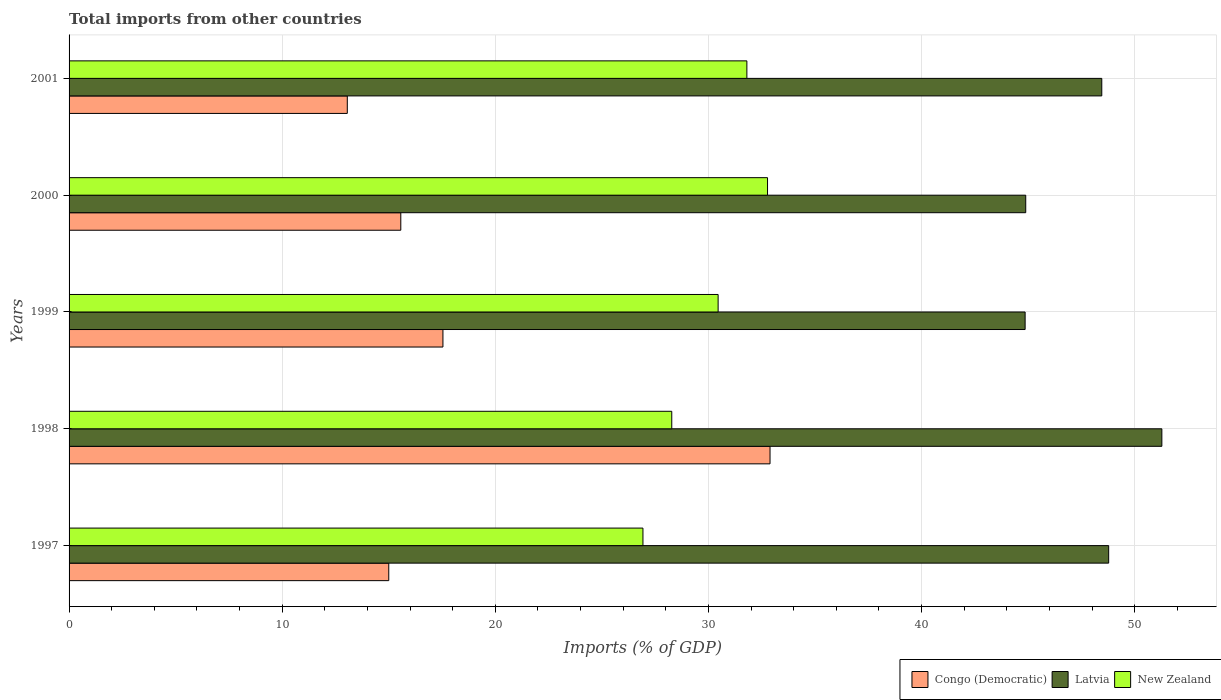How many different coloured bars are there?
Ensure brevity in your answer.  3. Are the number of bars per tick equal to the number of legend labels?
Give a very brief answer. Yes. How many bars are there on the 5th tick from the bottom?
Ensure brevity in your answer.  3. What is the label of the 5th group of bars from the top?
Offer a very short reply. 1997. What is the total imports in New Zealand in 1998?
Your answer should be very brief. 28.28. Across all years, what is the maximum total imports in Congo (Democratic)?
Your response must be concise. 32.89. Across all years, what is the minimum total imports in New Zealand?
Ensure brevity in your answer.  26.93. In which year was the total imports in New Zealand minimum?
Provide a short and direct response. 1997. What is the total total imports in Congo (Democratic) in the graph?
Ensure brevity in your answer.  94.05. What is the difference between the total imports in Congo (Democratic) in 1998 and that in 2001?
Provide a succinct answer. 19.83. What is the difference between the total imports in Congo (Democratic) in 2001 and the total imports in New Zealand in 1999?
Your response must be concise. -17.4. What is the average total imports in New Zealand per year?
Offer a very short reply. 30.05. In the year 1997, what is the difference between the total imports in Latvia and total imports in New Zealand?
Your response must be concise. 21.85. In how many years, is the total imports in Latvia greater than 4 %?
Offer a very short reply. 5. What is the ratio of the total imports in New Zealand in 1997 to that in 2001?
Your answer should be very brief. 0.85. Is the total imports in Congo (Democratic) in 1997 less than that in 2001?
Provide a short and direct response. No. Is the difference between the total imports in Latvia in 1998 and 2000 greater than the difference between the total imports in New Zealand in 1998 and 2000?
Ensure brevity in your answer.  Yes. What is the difference between the highest and the second highest total imports in Congo (Democratic)?
Offer a very short reply. 15.35. What is the difference between the highest and the lowest total imports in Latvia?
Offer a very short reply. 6.42. Is the sum of the total imports in New Zealand in 1998 and 1999 greater than the maximum total imports in Latvia across all years?
Make the answer very short. Yes. What does the 3rd bar from the top in 1999 represents?
Keep it short and to the point. Congo (Democratic). What does the 2nd bar from the bottom in 1998 represents?
Your answer should be compact. Latvia. What is the difference between two consecutive major ticks on the X-axis?
Your answer should be very brief. 10. Are the values on the major ticks of X-axis written in scientific E-notation?
Your response must be concise. No. Does the graph contain grids?
Offer a very short reply. Yes. What is the title of the graph?
Make the answer very short. Total imports from other countries. Does "Jordan" appear as one of the legend labels in the graph?
Give a very brief answer. No. What is the label or title of the X-axis?
Make the answer very short. Imports (% of GDP). What is the label or title of the Y-axis?
Provide a succinct answer. Years. What is the Imports (% of GDP) of Congo (Democratic) in 1997?
Provide a succinct answer. 15. What is the Imports (% of GDP) of Latvia in 1997?
Your response must be concise. 48.78. What is the Imports (% of GDP) of New Zealand in 1997?
Your answer should be very brief. 26.93. What is the Imports (% of GDP) of Congo (Democratic) in 1998?
Provide a succinct answer. 32.89. What is the Imports (% of GDP) in Latvia in 1998?
Your response must be concise. 51.27. What is the Imports (% of GDP) in New Zealand in 1998?
Provide a short and direct response. 28.28. What is the Imports (% of GDP) of Congo (Democratic) in 1999?
Give a very brief answer. 17.54. What is the Imports (% of GDP) in Latvia in 1999?
Your answer should be compact. 44.86. What is the Imports (% of GDP) of New Zealand in 1999?
Provide a short and direct response. 30.45. What is the Imports (% of GDP) of Congo (Democratic) in 2000?
Your response must be concise. 15.56. What is the Imports (% of GDP) of Latvia in 2000?
Offer a very short reply. 44.89. What is the Imports (% of GDP) of New Zealand in 2000?
Your response must be concise. 32.77. What is the Imports (% of GDP) of Congo (Democratic) in 2001?
Your response must be concise. 13.05. What is the Imports (% of GDP) of Latvia in 2001?
Give a very brief answer. 48.46. What is the Imports (% of GDP) in New Zealand in 2001?
Offer a very short reply. 31.8. Across all years, what is the maximum Imports (% of GDP) of Congo (Democratic)?
Offer a very short reply. 32.89. Across all years, what is the maximum Imports (% of GDP) of Latvia?
Make the answer very short. 51.27. Across all years, what is the maximum Imports (% of GDP) of New Zealand?
Give a very brief answer. 32.77. Across all years, what is the minimum Imports (% of GDP) of Congo (Democratic)?
Provide a short and direct response. 13.05. Across all years, what is the minimum Imports (% of GDP) of Latvia?
Keep it short and to the point. 44.86. Across all years, what is the minimum Imports (% of GDP) of New Zealand?
Make the answer very short. 26.93. What is the total Imports (% of GDP) of Congo (Democratic) in the graph?
Provide a short and direct response. 94.05. What is the total Imports (% of GDP) in Latvia in the graph?
Give a very brief answer. 238.25. What is the total Imports (% of GDP) in New Zealand in the graph?
Make the answer very short. 150.23. What is the difference between the Imports (% of GDP) of Congo (Democratic) in 1997 and that in 1998?
Offer a very short reply. -17.89. What is the difference between the Imports (% of GDP) of Latvia in 1997 and that in 1998?
Ensure brevity in your answer.  -2.5. What is the difference between the Imports (% of GDP) of New Zealand in 1997 and that in 1998?
Your answer should be compact. -1.35. What is the difference between the Imports (% of GDP) of Congo (Democratic) in 1997 and that in 1999?
Your response must be concise. -2.54. What is the difference between the Imports (% of GDP) of Latvia in 1997 and that in 1999?
Give a very brief answer. 3.92. What is the difference between the Imports (% of GDP) of New Zealand in 1997 and that in 1999?
Provide a succinct answer. -3.53. What is the difference between the Imports (% of GDP) of Congo (Democratic) in 1997 and that in 2000?
Your answer should be compact. -0.56. What is the difference between the Imports (% of GDP) of Latvia in 1997 and that in 2000?
Ensure brevity in your answer.  3.89. What is the difference between the Imports (% of GDP) in New Zealand in 1997 and that in 2000?
Provide a short and direct response. -5.85. What is the difference between the Imports (% of GDP) of Congo (Democratic) in 1997 and that in 2001?
Ensure brevity in your answer.  1.95. What is the difference between the Imports (% of GDP) of Latvia in 1997 and that in 2001?
Your answer should be very brief. 0.32. What is the difference between the Imports (% of GDP) of New Zealand in 1997 and that in 2001?
Your answer should be compact. -4.88. What is the difference between the Imports (% of GDP) in Congo (Democratic) in 1998 and that in 1999?
Provide a short and direct response. 15.35. What is the difference between the Imports (% of GDP) of Latvia in 1998 and that in 1999?
Keep it short and to the point. 6.42. What is the difference between the Imports (% of GDP) of New Zealand in 1998 and that in 1999?
Ensure brevity in your answer.  -2.18. What is the difference between the Imports (% of GDP) in Congo (Democratic) in 1998 and that in 2000?
Ensure brevity in your answer.  17.32. What is the difference between the Imports (% of GDP) of Latvia in 1998 and that in 2000?
Offer a very short reply. 6.39. What is the difference between the Imports (% of GDP) in New Zealand in 1998 and that in 2000?
Your response must be concise. -4.49. What is the difference between the Imports (% of GDP) in Congo (Democratic) in 1998 and that in 2001?
Ensure brevity in your answer.  19.84. What is the difference between the Imports (% of GDP) of Latvia in 1998 and that in 2001?
Your answer should be compact. 2.82. What is the difference between the Imports (% of GDP) in New Zealand in 1998 and that in 2001?
Offer a very short reply. -3.52. What is the difference between the Imports (% of GDP) in Congo (Democratic) in 1999 and that in 2000?
Make the answer very short. 1.98. What is the difference between the Imports (% of GDP) of Latvia in 1999 and that in 2000?
Give a very brief answer. -0.03. What is the difference between the Imports (% of GDP) in New Zealand in 1999 and that in 2000?
Offer a terse response. -2.32. What is the difference between the Imports (% of GDP) of Congo (Democratic) in 1999 and that in 2001?
Provide a succinct answer. 4.49. What is the difference between the Imports (% of GDP) of Latvia in 1999 and that in 2001?
Your answer should be very brief. -3.6. What is the difference between the Imports (% of GDP) in New Zealand in 1999 and that in 2001?
Your response must be concise. -1.35. What is the difference between the Imports (% of GDP) of Congo (Democratic) in 2000 and that in 2001?
Keep it short and to the point. 2.51. What is the difference between the Imports (% of GDP) of Latvia in 2000 and that in 2001?
Your answer should be compact. -3.57. What is the difference between the Imports (% of GDP) of New Zealand in 2000 and that in 2001?
Ensure brevity in your answer.  0.97. What is the difference between the Imports (% of GDP) in Congo (Democratic) in 1997 and the Imports (% of GDP) in Latvia in 1998?
Give a very brief answer. -36.27. What is the difference between the Imports (% of GDP) of Congo (Democratic) in 1997 and the Imports (% of GDP) of New Zealand in 1998?
Your response must be concise. -13.28. What is the difference between the Imports (% of GDP) in Latvia in 1997 and the Imports (% of GDP) in New Zealand in 1998?
Your answer should be very brief. 20.5. What is the difference between the Imports (% of GDP) in Congo (Democratic) in 1997 and the Imports (% of GDP) in Latvia in 1999?
Offer a terse response. -29.86. What is the difference between the Imports (% of GDP) of Congo (Democratic) in 1997 and the Imports (% of GDP) of New Zealand in 1999?
Ensure brevity in your answer.  -15.45. What is the difference between the Imports (% of GDP) in Latvia in 1997 and the Imports (% of GDP) in New Zealand in 1999?
Make the answer very short. 18.32. What is the difference between the Imports (% of GDP) of Congo (Democratic) in 1997 and the Imports (% of GDP) of Latvia in 2000?
Your answer should be compact. -29.89. What is the difference between the Imports (% of GDP) of Congo (Democratic) in 1997 and the Imports (% of GDP) of New Zealand in 2000?
Offer a very short reply. -17.77. What is the difference between the Imports (% of GDP) of Latvia in 1997 and the Imports (% of GDP) of New Zealand in 2000?
Your answer should be compact. 16.01. What is the difference between the Imports (% of GDP) of Congo (Democratic) in 1997 and the Imports (% of GDP) of Latvia in 2001?
Give a very brief answer. -33.45. What is the difference between the Imports (% of GDP) in Congo (Democratic) in 1997 and the Imports (% of GDP) in New Zealand in 2001?
Offer a very short reply. -16.8. What is the difference between the Imports (% of GDP) of Latvia in 1997 and the Imports (% of GDP) of New Zealand in 2001?
Make the answer very short. 16.98. What is the difference between the Imports (% of GDP) of Congo (Democratic) in 1998 and the Imports (% of GDP) of Latvia in 1999?
Keep it short and to the point. -11.97. What is the difference between the Imports (% of GDP) in Congo (Democratic) in 1998 and the Imports (% of GDP) in New Zealand in 1999?
Keep it short and to the point. 2.44. What is the difference between the Imports (% of GDP) of Latvia in 1998 and the Imports (% of GDP) of New Zealand in 1999?
Keep it short and to the point. 20.82. What is the difference between the Imports (% of GDP) in Congo (Democratic) in 1998 and the Imports (% of GDP) in Latvia in 2000?
Ensure brevity in your answer.  -12. What is the difference between the Imports (% of GDP) in Congo (Democratic) in 1998 and the Imports (% of GDP) in New Zealand in 2000?
Provide a short and direct response. 0.12. What is the difference between the Imports (% of GDP) in Latvia in 1998 and the Imports (% of GDP) in New Zealand in 2000?
Make the answer very short. 18.5. What is the difference between the Imports (% of GDP) in Congo (Democratic) in 1998 and the Imports (% of GDP) in Latvia in 2001?
Offer a very short reply. -15.57. What is the difference between the Imports (% of GDP) in Congo (Democratic) in 1998 and the Imports (% of GDP) in New Zealand in 2001?
Make the answer very short. 1.09. What is the difference between the Imports (% of GDP) of Latvia in 1998 and the Imports (% of GDP) of New Zealand in 2001?
Keep it short and to the point. 19.47. What is the difference between the Imports (% of GDP) of Congo (Democratic) in 1999 and the Imports (% of GDP) of Latvia in 2000?
Provide a succinct answer. -27.35. What is the difference between the Imports (% of GDP) in Congo (Democratic) in 1999 and the Imports (% of GDP) in New Zealand in 2000?
Ensure brevity in your answer.  -15.23. What is the difference between the Imports (% of GDP) of Latvia in 1999 and the Imports (% of GDP) of New Zealand in 2000?
Offer a terse response. 12.09. What is the difference between the Imports (% of GDP) in Congo (Democratic) in 1999 and the Imports (% of GDP) in Latvia in 2001?
Ensure brevity in your answer.  -30.91. What is the difference between the Imports (% of GDP) in Congo (Democratic) in 1999 and the Imports (% of GDP) in New Zealand in 2001?
Your answer should be very brief. -14.26. What is the difference between the Imports (% of GDP) of Latvia in 1999 and the Imports (% of GDP) of New Zealand in 2001?
Your answer should be very brief. 13.06. What is the difference between the Imports (% of GDP) in Congo (Democratic) in 2000 and the Imports (% of GDP) in Latvia in 2001?
Your answer should be very brief. -32.89. What is the difference between the Imports (% of GDP) in Congo (Democratic) in 2000 and the Imports (% of GDP) in New Zealand in 2001?
Offer a terse response. -16.24. What is the difference between the Imports (% of GDP) of Latvia in 2000 and the Imports (% of GDP) of New Zealand in 2001?
Provide a short and direct response. 13.08. What is the average Imports (% of GDP) of Congo (Democratic) per year?
Provide a succinct answer. 18.81. What is the average Imports (% of GDP) in Latvia per year?
Ensure brevity in your answer.  47.65. What is the average Imports (% of GDP) in New Zealand per year?
Your response must be concise. 30.05. In the year 1997, what is the difference between the Imports (% of GDP) in Congo (Democratic) and Imports (% of GDP) in Latvia?
Keep it short and to the point. -33.78. In the year 1997, what is the difference between the Imports (% of GDP) in Congo (Democratic) and Imports (% of GDP) in New Zealand?
Provide a short and direct response. -11.93. In the year 1997, what is the difference between the Imports (% of GDP) in Latvia and Imports (% of GDP) in New Zealand?
Give a very brief answer. 21.85. In the year 1998, what is the difference between the Imports (% of GDP) of Congo (Democratic) and Imports (% of GDP) of Latvia?
Provide a short and direct response. -18.38. In the year 1998, what is the difference between the Imports (% of GDP) of Congo (Democratic) and Imports (% of GDP) of New Zealand?
Provide a succinct answer. 4.61. In the year 1998, what is the difference between the Imports (% of GDP) of Latvia and Imports (% of GDP) of New Zealand?
Your response must be concise. 23. In the year 1999, what is the difference between the Imports (% of GDP) in Congo (Democratic) and Imports (% of GDP) in Latvia?
Provide a short and direct response. -27.32. In the year 1999, what is the difference between the Imports (% of GDP) of Congo (Democratic) and Imports (% of GDP) of New Zealand?
Keep it short and to the point. -12.91. In the year 1999, what is the difference between the Imports (% of GDP) of Latvia and Imports (% of GDP) of New Zealand?
Give a very brief answer. 14.4. In the year 2000, what is the difference between the Imports (% of GDP) in Congo (Democratic) and Imports (% of GDP) in Latvia?
Offer a terse response. -29.32. In the year 2000, what is the difference between the Imports (% of GDP) of Congo (Democratic) and Imports (% of GDP) of New Zealand?
Your response must be concise. -17.21. In the year 2000, what is the difference between the Imports (% of GDP) of Latvia and Imports (% of GDP) of New Zealand?
Give a very brief answer. 12.12. In the year 2001, what is the difference between the Imports (% of GDP) in Congo (Democratic) and Imports (% of GDP) in Latvia?
Offer a very short reply. -35.4. In the year 2001, what is the difference between the Imports (% of GDP) in Congo (Democratic) and Imports (% of GDP) in New Zealand?
Your response must be concise. -18.75. In the year 2001, what is the difference between the Imports (% of GDP) of Latvia and Imports (% of GDP) of New Zealand?
Offer a terse response. 16.65. What is the ratio of the Imports (% of GDP) in Congo (Democratic) in 1997 to that in 1998?
Ensure brevity in your answer.  0.46. What is the ratio of the Imports (% of GDP) of Latvia in 1997 to that in 1998?
Provide a succinct answer. 0.95. What is the ratio of the Imports (% of GDP) in New Zealand in 1997 to that in 1998?
Ensure brevity in your answer.  0.95. What is the ratio of the Imports (% of GDP) of Congo (Democratic) in 1997 to that in 1999?
Offer a very short reply. 0.86. What is the ratio of the Imports (% of GDP) of Latvia in 1997 to that in 1999?
Your answer should be very brief. 1.09. What is the ratio of the Imports (% of GDP) of New Zealand in 1997 to that in 1999?
Keep it short and to the point. 0.88. What is the ratio of the Imports (% of GDP) of Congo (Democratic) in 1997 to that in 2000?
Offer a very short reply. 0.96. What is the ratio of the Imports (% of GDP) in Latvia in 1997 to that in 2000?
Offer a very short reply. 1.09. What is the ratio of the Imports (% of GDP) of New Zealand in 1997 to that in 2000?
Your answer should be very brief. 0.82. What is the ratio of the Imports (% of GDP) of Congo (Democratic) in 1997 to that in 2001?
Make the answer very short. 1.15. What is the ratio of the Imports (% of GDP) of New Zealand in 1997 to that in 2001?
Make the answer very short. 0.85. What is the ratio of the Imports (% of GDP) of Congo (Democratic) in 1998 to that in 1999?
Your response must be concise. 1.87. What is the ratio of the Imports (% of GDP) of Latvia in 1998 to that in 1999?
Provide a short and direct response. 1.14. What is the ratio of the Imports (% of GDP) of New Zealand in 1998 to that in 1999?
Give a very brief answer. 0.93. What is the ratio of the Imports (% of GDP) of Congo (Democratic) in 1998 to that in 2000?
Your answer should be compact. 2.11. What is the ratio of the Imports (% of GDP) in Latvia in 1998 to that in 2000?
Your response must be concise. 1.14. What is the ratio of the Imports (% of GDP) of New Zealand in 1998 to that in 2000?
Your answer should be very brief. 0.86. What is the ratio of the Imports (% of GDP) of Congo (Democratic) in 1998 to that in 2001?
Give a very brief answer. 2.52. What is the ratio of the Imports (% of GDP) of Latvia in 1998 to that in 2001?
Give a very brief answer. 1.06. What is the ratio of the Imports (% of GDP) in New Zealand in 1998 to that in 2001?
Offer a very short reply. 0.89. What is the ratio of the Imports (% of GDP) in Congo (Democratic) in 1999 to that in 2000?
Ensure brevity in your answer.  1.13. What is the ratio of the Imports (% of GDP) of New Zealand in 1999 to that in 2000?
Your answer should be very brief. 0.93. What is the ratio of the Imports (% of GDP) of Congo (Democratic) in 1999 to that in 2001?
Give a very brief answer. 1.34. What is the ratio of the Imports (% of GDP) of Latvia in 1999 to that in 2001?
Provide a short and direct response. 0.93. What is the ratio of the Imports (% of GDP) in New Zealand in 1999 to that in 2001?
Ensure brevity in your answer.  0.96. What is the ratio of the Imports (% of GDP) of Congo (Democratic) in 2000 to that in 2001?
Your response must be concise. 1.19. What is the ratio of the Imports (% of GDP) of Latvia in 2000 to that in 2001?
Your answer should be compact. 0.93. What is the ratio of the Imports (% of GDP) of New Zealand in 2000 to that in 2001?
Offer a very short reply. 1.03. What is the difference between the highest and the second highest Imports (% of GDP) of Congo (Democratic)?
Make the answer very short. 15.35. What is the difference between the highest and the second highest Imports (% of GDP) in Latvia?
Provide a succinct answer. 2.5. What is the difference between the highest and the second highest Imports (% of GDP) in New Zealand?
Provide a succinct answer. 0.97. What is the difference between the highest and the lowest Imports (% of GDP) of Congo (Democratic)?
Offer a very short reply. 19.84. What is the difference between the highest and the lowest Imports (% of GDP) in Latvia?
Your answer should be very brief. 6.42. What is the difference between the highest and the lowest Imports (% of GDP) of New Zealand?
Offer a terse response. 5.85. 